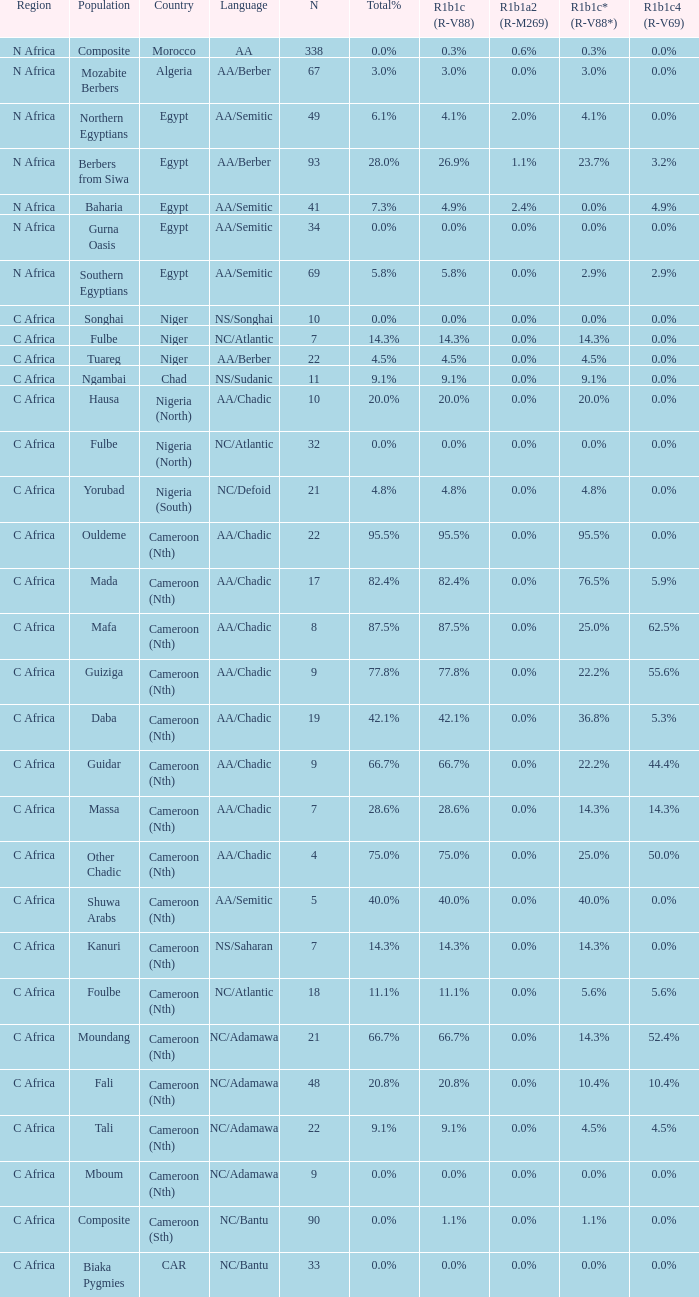Could you parse the entire table as a dict? {'header': ['Region', 'Population', 'Country', 'Language', 'N', 'Total%', 'R1b1c (R-V88)', 'R1b1a2 (R-M269)', 'R1b1c* (R-V88*)', 'R1b1c4 (R-V69)'], 'rows': [['N Africa', 'Composite', 'Morocco', 'AA', '338', '0.0%', '0.3%', '0.6%', '0.3%', '0.0%'], ['N Africa', 'Mozabite Berbers', 'Algeria', 'AA/Berber', '67', '3.0%', '3.0%', '0.0%', '3.0%', '0.0%'], ['N Africa', 'Northern Egyptians', 'Egypt', 'AA/Semitic', '49', '6.1%', '4.1%', '2.0%', '4.1%', '0.0%'], ['N Africa', 'Berbers from Siwa', 'Egypt', 'AA/Berber', '93', '28.0%', '26.9%', '1.1%', '23.7%', '3.2%'], ['N Africa', 'Baharia', 'Egypt', 'AA/Semitic', '41', '7.3%', '4.9%', '2.4%', '0.0%', '4.9%'], ['N Africa', 'Gurna Oasis', 'Egypt', 'AA/Semitic', '34', '0.0%', '0.0%', '0.0%', '0.0%', '0.0%'], ['N Africa', 'Southern Egyptians', 'Egypt', 'AA/Semitic', '69', '5.8%', '5.8%', '0.0%', '2.9%', '2.9%'], ['C Africa', 'Songhai', 'Niger', 'NS/Songhai', '10', '0.0%', '0.0%', '0.0%', '0.0%', '0.0%'], ['C Africa', 'Fulbe', 'Niger', 'NC/Atlantic', '7', '14.3%', '14.3%', '0.0%', '14.3%', '0.0%'], ['C Africa', 'Tuareg', 'Niger', 'AA/Berber', '22', '4.5%', '4.5%', '0.0%', '4.5%', '0.0%'], ['C Africa', 'Ngambai', 'Chad', 'NS/Sudanic', '11', '9.1%', '9.1%', '0.0%', '9.1%', '0.0%'], ['C Africa', 'Hausa', 'Nigeria (North)', 'AA/Chadic', '10', '20.0%', '20.0%', '0.0%', '20.0%', '0.0%'], ['C Africa', 'Fulbe', 'Nigeria (North)', 'NC/Atlantic', '32', '0.0%', '0.0%', '0.0%', '0.0%', '0.0%'], ['C Africa', 'Yorubad', 'Nigeria (South)', 'NC/Defoid', '21', '4.8%', '4.8%', '0.0%', '4.8%', '0.0%'], ['C Africa', 'Ouldeme', 'Cameroon (Nth)', 'AA/Chadic', '22', '95.5%', '95.5%', '0.0%', '95.5%', '0.0%'], ['C Africa', 'Mada', 'Cameroon (Nth)', 'AA/Chadic', '17', '82.4%', '82.4%', '0.0%', '76.5%', '5.9%'], ['C Africa', 'Mafa', 'Cameroon (Nth)', 'AA/Chadic', '8', '87.5%', '87.5%', '0.0%', '25.0%', '62.5%'], ['C Africa', 'Guiziga', 'Cameroon (Nth)', 'AA/Chadic', '9', '77.8%', '77.8%', '0.0%', '22.2%', '55.6%'], ['C Africa', 'Daba', 'Cameroon (Nth)', 'AA/Chadic', '19', '42.1%', '42.1%', '0.0%', '36.8%', '5.3%'], ['C Africa', 'Guidar', 'Cameroon (Nth)', 'AA/Chadic', '9', '66.7%', '66.7%', '0.0%', '22.2%', '44.4%'], ['C Africa', 'Massa', 'Cameroon (Nth)', 'AA/Chadic', '7', '28.6%', '28.6%', '0.0%', '14.3%', '14.3%'], ['C Africa', 'Other Chadic', 'Cameroon (Nth)', 'AA/Chadic', '4', '75.0%', '75.0%', '0.0%', '25.0%', '50.0%'], ['C Africa', 'Shuwa Arabs', 'Cameroon (Nth)', 'AA/Semitic', '5', '40.0%', '40.0%', '0.0%', '40.0%', '0.0%'], ['C Africa', 'Kanuri', 'Cameroon (Nth)', 'NS/Saharan', '7', '14.3%', '14.3%', '0.0%', '14.3%', '0.0%'], ['C Africa', 'Foulbe', 'Cameroon (Nth)', 'NC/Atlantic', '18', '11.1%', '11.1%', '0.0%', '5.6%', '5.6%'], ['C Africa', 'Moundang', 'Cameroon (Nth)', 'NC/Adamawa', '21', '66.7%', '66.7%', '0.0%', '14.3%', '52.4%'], ['C Africa', 'Fali', 'Cameroon (Nth)', 'NC/Adamawa', '48', '20.8%', '20.8%', '0.0%', '10.4%', '10.4%'], ['C Africa', 'Tali', 'Cameroon (Nth)', 'NC/Adamawa', '22', '9.1%', '9.1%', '0.0%', '4.5%', '4.5%'], ['C Africa', 'Mboum', 'Cameroon (Nth)', 'NC/Adamawa', '9', '0.0%', '0.0%', '0.0%', '0.0%', '0.0%'], ['C Africa', 'Composite', 'Cameroon (Sth)', 'NC/Bantu', '90', '0.0%', '1.1%', '0.0%', '1.1%', '0.0%'], ['C Africa', 'Biaka Pygmies', 'CAR', 'NC/Bantu', '33', '0.0%', '0.0%', '0.0%', '0.0%', '0.0%']]} What is the greatest n value for 5 9.0. 